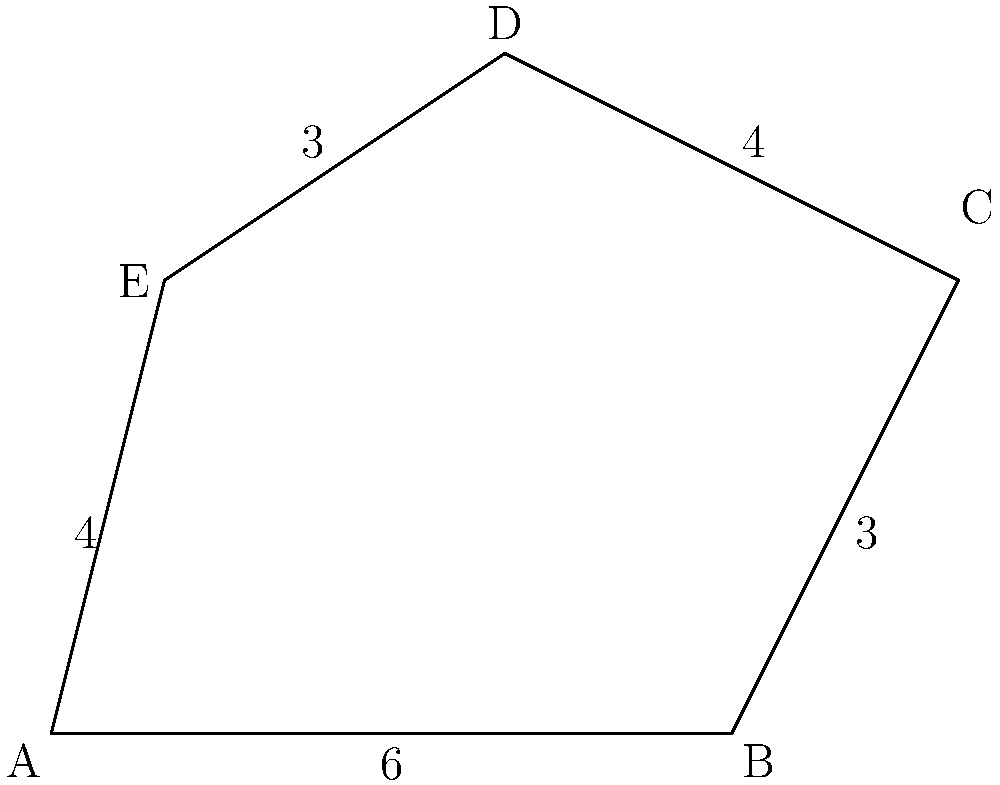Given the irregular property lot shown in the diagram, with sides measured in hundreds of feet, calculate the total perimeter of the lot. How might this information be useful in estimating fencing costs or property boundaries? To calculate the perimeter of the irregular property lot, we need to sum up the lengths of all sides:

1. Side AB: 6 hundred feet
2. Side BC: 3 hundred feet
3. Side CD: 4 hundred feet
4. Side DE: 3 hundred feet
5. Side EA: 4 hundred feet

Total perimeter = AB + BC + CD + DE + EA
$$ \text{Perimeter} = 6 + 3 + 4 + 3 + 4 = 20 \text{ hundred feet} $$

Converting to standard feet:
$$ 20 \times 100 = 2000 \text{ feet} $$

This information is crucial for:
1. Estimating fencing costs: Multiply the perimeter by the cost per linear foot of fencing.
2. Defining property boundaries: Ensures accurate property lines for legal and practical purposes.
3. Landscaping planning: Helps in calculating materials needed for border plantings or edging.
4. Security considerations: Useful for planning surveillance or lighting around the property.
Answer: 2000 feet 